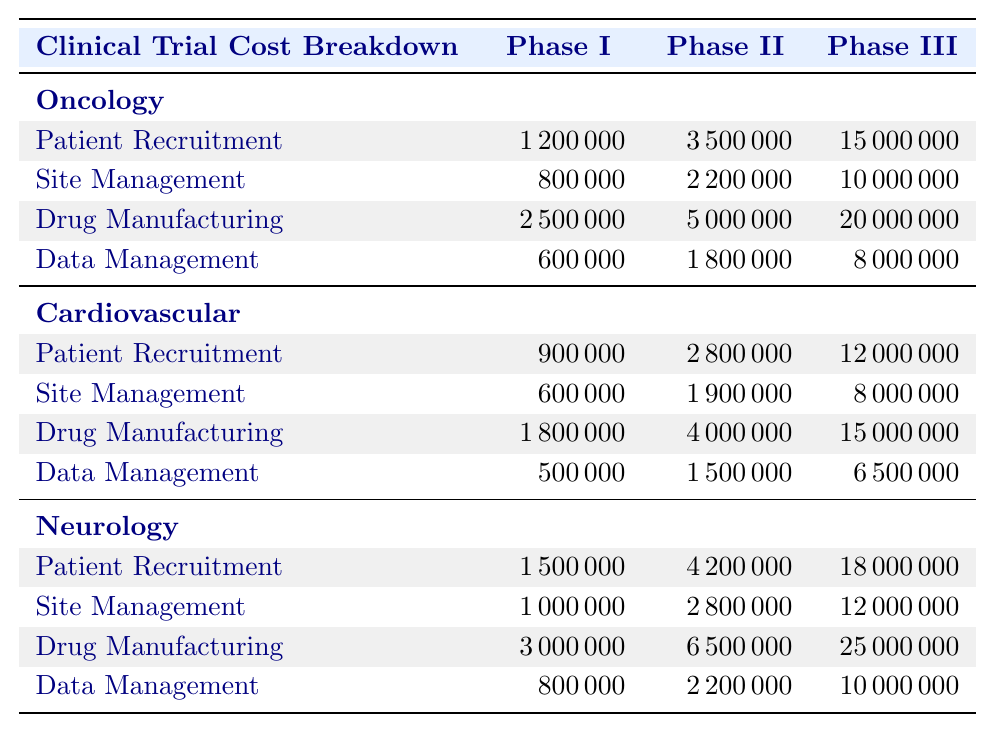What is the total cost of Phase III trials in Oncology? To find the total cost of Phase III trials in Oncology, we sum the costs for all components in Phase III: Patient Recruitment ($15,000,000) + Site Management ($10,000,000) + Drug Manufacturing ($20,000,000) + Data Management ($8,000,000). Adding these gives us $15,000,000 + $10,000,000 + $20,000,000 + $8,000,000 = $53,000,000.
Answer: $53,000,000 Which therapeutic category has the highest total cost for Phase II trials? We calculate the total cost of Phase II trials for each therapeutic category: Oncology ($3,500,000 + $2,200,000 + $5,000,000 + $1,800,000 = $12,500,000), Cardiovascular ($2,800,000 + $1,900,000 + $4,000,000 + $1,500,000 = $10,200,000), and Neurology ($4,200,000 + $2,800,000 + $6,500,000 + $2,200,000 = $15,700,000). Neurology has the highest total of $15,700,000.
Answer: Neurology Is the cost of Data Management higher in Phase III trials than in Phase I across all therapeutic categories? We compare the Data Management costs: Oncology Phase III ($8,000,000) vs. Phase I ($600,000), Cardiovascular Phase III ($6,500,000) vs. Phase I ($500,000), and Neurology Phase III ($10,000,000) vs. Phase I ($800,000). In all comparisons, Phase III costs are higher.
Answer: Yes What is the average cost of Patient Recruitment across all phases for Neurology? The costs for Patient Recruitment in Neurology phases are: Phase I ($1,500,000), Phase II ($4,200,000), and Phase III ($18,000,000). We sum these: $1,500,000 + $4,200,000 + $18,000,000 = $23,700,000. Then, we divide by the number of phases (3): $23,700,000 / 3 = $7,900,000.
Answer: $7,900,000 For Phase II trials, how much more expensive is Drug Manufacturing in Oncology compared to Cardiovascular? We compare the costs: Oncology Drug Manufacturing Phase II is $5,000,000 and Cardiovascular is $4,000,000. The difference is $5,000,000 - $4,000,000 = $1,000,000. Thus, Drug Manufacturing in Oncology is $1,000,000 more expensive.
Answer: $1,000,000 Which phase in Oncology has the lowest total cost? We need to find the total costs for each phase in Oncology: Phase I ($1,200,000 + $800,000 + $2,500,000 + $600,000 = $5,100,000), Phase II ($3,500,000 + $2,200,000 + $5,000,000 + $1,800,000 = $12,500,000), and Phase III ($15,000,000 + $10,000,000 + $20,000,000 + $8,000,000 = $53,000,000). The lowest total is for Phase I at $5,100,000.
Answer: Phase I What is the total cost of Site Management across all therapeutic categories for Phase I? We calculate Site Management costs for Phase I: Oncology ($800,000), Cardiovascular ($600,000), and Neurology ($1,000,000). Summing these gives us $800,000 + $600,000 + $1,000,000 = $2,400,000.
Answer: $2,400,000 Does the total cost of Phase III trials exceed $50 million across any therapeutic category? We check the totals for Phase III: Oncology is $53,000,000, Cardiovascular is $46,500,000, and Neurology is $55,000,000. Both Oncology and Neurology exceed $50 million.
Answer: Yes What is the cost ratio of Drug Manufacturing to Patient Recruitment in Phase III for Cardiovascular? The costs for Cardiovascular are: Drug Manufacturing Phase III ($15,000,000) and Patient Recruitment Phase III ($12,000,000). The ratio is calculated as $15,000,000 / $12,000,000 = 1.25.
Answer: 1.25 Which therapeutic category has the most expensive Data Management in Phase II? We compare costs for Phase II Data Management: Oncology ($1,800,000), Cardiovascular ($1,500,000), and Neurology ($2,200,000). Neurology has the highest cost at $2,200,000.
Answer: Neurology 